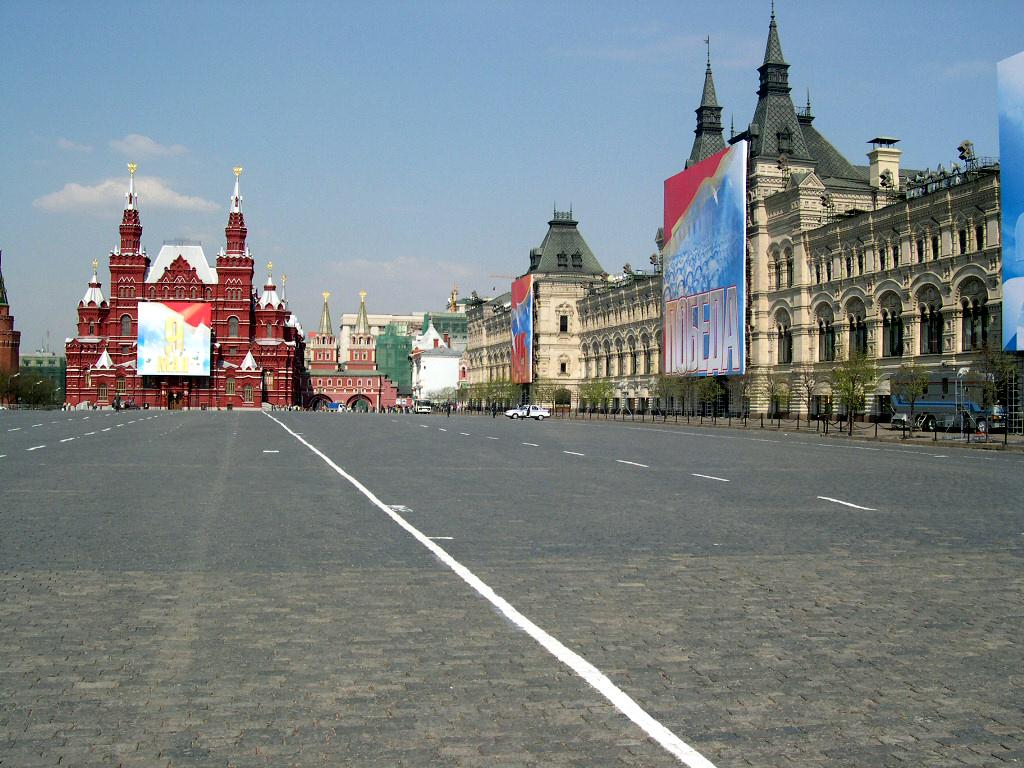What types of objects are present in the image? There are vehicles in the image. What else can be seen on the road in the image? There are trees on the road in the image. What can be seen in the distance in the image? There are buildings and banners in the background of the image. What is visible above the buildings and banners in the image? The sky is visible in the background of the image. What type of agreement is being signed by the son in the image? There is no son or agreement present in the image. 